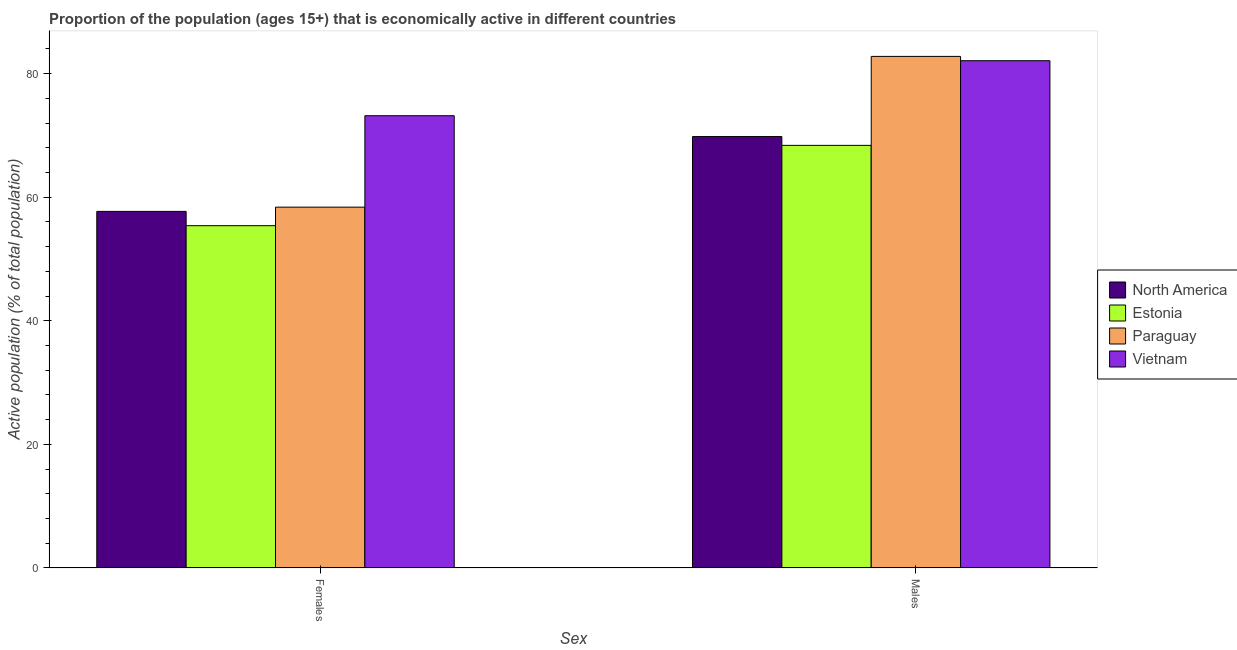How many groups of bars are there?
Your answer should be very brief. 2. Are the number of bars on each tick of the X-axis equal?
Ensure brevity in your answer.  Yes. What is the label of the 1st group of bars from the left?
Give a very brief answer. Females. What is the percentage of economically active male population in Vietnam?
Give a very brief answer. 82.1. Across all countries, what is the maximum percentage of economically active female population?
Make the answer very short. 73.2. Across all countries, what is the minimum percentage of economically active female population?
Offer a very short reply. 55.4. In which country was the percentage of economically active male population maximum?
Provide a succinct answer. Paraguay. In which country was the percentage of economically active female population minimum?
Offer a very short reply. Estonia. What is the total percentage of economically active male population in the graph?
Your answer should be very brief. 303.12. What is the difference between the percentage of economically active male population in Estonia and that in Paraguay?
Ensure brevity in your answer.  -14.4. What is the difference between the percentage of economically active male population in North America and the percentage of economically active female population in Estonia?
Your answer should be compact. 14.42. What is the average percentage of economically active male population per country?
Give a very brief answer. 75.78. What is the difference between the percentage of economically active female population and percentage of economically active male population in Estonia?
Provide a short and direct response. -13. What is the ratio of the percentage of economically active male population in Paraguay to that in North America?
Your response must be concise. 1.19. Is the percentage of economically active female population in Vietnam less than that in North America?
Keep it short and to the point. No. What does the 1st bar from the left in Females represents?
Your answer should be compact. North America. What does the 3rd bar from the right in Females represents?
Provide a short and direct response. Estonia. How many bars are there?
Provide a short and direct response. 8. How many countries are there in the graph?
Your response must be concise. 4. What is the difference between two consecutive major ticks on the Y-axis?
Provide a short and direct response. 20. How many legend labels are there?
Provide a succinct answer. 4. What is the title of the graph?
Your answer should be very brief. Proportion of the population (ages 15+) that is economically active in different countries. What is the label or title of the X-axis?
Provide a short and direct response. Sex. What is the label or title of the Y-axis?
Give a very brief answer. Active population (% of total population). What is the Active population (% of total population) in North America in Females?
Offer a terse response. 57.72. What is the Active population (% of total population) of Estonia in Females?
Provide a succinct answer. 55.4. What is the Active population (% of total population) of Paraguay in Females?
Your answer should be very brief. 58.4. What is the Active population (% of total population) in Vietnam in Females?
Give a very brief answer. 73.2. What is the Active population (% of total population) of North America in Males?
Your response must be concise. 69.82. What is the Active population (% of total population) in Estonia in Males?
Your answer should be very brief. 68.4. What is the Active population (% of total population) of Paraguay in Males?
Offer a very short reply. 82.8. What is the Active population (% of total population) in Vietnam in Males?
Offer a very short reply. 82.1. Across all Sex, what is the maximum Active population (% of total population) in North America?
Provide a succinct answer. 69.82. Across all Sex, what is the maximum Active population (% of total population) of Estonia?
Offer a very short reply. 68.4. Across all Sex, what is the maximum Active population (% of total population) of Paraguay?
Keep it short and to the point. 82.8. Across all Sex, what is the maximum Active population (% of total population) in Vietnam?
Offer a very short reply. 82.1. Across all Sex, what is the minimum Active population (% of total population) of North America?
Give a very brief answer. 57.72. Across all Sex, what is the minimum Active population (% of total population) of Estonia?
Provide a short and direct response. 55.4. Across all Sex, what is the minimum Active population (% of total population) of Paraguay?
Give a very brief answer. 58.4. Across all Sex, what is the minimum Active population (% of total population) of Vietnam?
Your answer should be very brief. 73.2. What is the total Active population (% of total population) in North America in the graph?
Your answer should be very brief. 127.54. What is the total Active population (% of total population) in Estonia in the graph?
Make the answer very short. 123.8. What is the total Active population (% of total population) of Paraguay in the graph?
Offer a very short reply. 141.2. What is the total Active population (% of total population) of Vietnam in the graph?
Provide a short and direct response. 155.3. What is the difference between the Active population (% of total population) in North America in Females and that in Males?
Keep it short and to the point. -12.11. What is the difference between the Active population (% of total population) in Estonia in Females and that in Males?
Provide a short and direct response. -13. What is the difference between the Active population (% of total population) in Paraguay in Females and that in Males?
Offer a terse response. -24.4. What is the difference between the Active population (% of total population) in Vietnam in Females and that in Males?
Offer a very short reply. -8.9. What is the difference between the Active population (% of total population) of North America in Females and the Active population (% of total population) of Estonia in Males?
Your response must be concise. -10.68. What is the difference between the Active population (% of total population) of North America in Females and the Active population (% of total population) of Paraguay in Males?
Your answer should be compact. -25.08. What is the difference between the Active population (% of total population) of North America in Females and the Active population (% of total population) of Vietnam in Males?
Give a very brief answer. -24.38. What is the difference between the Active population (% of total population) of Estonia in Females and the Active population (% of total population) of Paraguay in Males?
Keep it short and to the point. -27.4. What is the difference between the Active population (% of total population) of Estonia in Females and the Active population (% of total population) of Vietnam in Males?
Give a very brief answer. -26.7. What is the difference between the Active population (% of total population) in Paraguay in Females and the Active population (% of total population) in Vietnam in Males?
Offer a terse response. -23.7. What is the average Active population (% of total population) in North America per Sex?
Provide a succinct answer. 63.77. What is the average Active population (% of total population) in Estonia per Sex?
Offer a terse response. 61.9. What is the average Active population (% of total population) of Paraguay per Sex?
Provide a short and direct response. 70.6. What is the average Active population (% of total population) of Vietnam per Sex?
Make the answer very short. 77.65. What is the difference between the Active population (% of total population) in North America and Active population (% of total population) in Estonia in Females?
Offer a terse response. 2.32. What is the difference between the Active population (% of total population) of North America and Active population (% of total population) of Paraguay in Females?
Provide a short and direct response. -0.68. What is the difference between the Active population (% of total population) of North America and Active population (% of total population) of Vietnam in Females?
Give a very brief answer. -15.48. What is the difference between the Active population (% of total population) in Estonia and Active population (% of total population) in Paraguay in Females?
Keep it short and to the point. -3. What is the difference between the Active population (% of total population) of Estonia and Active population (% of total population) of Vietnam in Females?
Offer a terse response. -17.8. What is the difference between the Active population (% of total population) in Paraguay and Active population (% of total population) in Vietnam in Females?
Provide a succinct answer. -14.8. What is the difference between the Active population (% of total population) in North America and Active population (% of total population) in Estonia in Males?
Make the answer very short. 1.42. What is the difference between the Active population (% of total population) in North America and Active population (% of total population) in Paraguay in Males?
Your answer should be very brief. -12.98. What is the difference between the Active population (% of total population) in North America and Active population (% of total population) in Vietnam in Males?
Your response must be concise. -12.28. What is the difference between the Active population (% of total population) of Estonia and Active population (% of total population) of Paraguay in Males?
Keep it short and to the point. -14.4. What is the difference between the Active population (% of total population) in Estonia and Active population (% of total population) in Vietnam in Males?
Provide a short and direct response. -13.7. What is the difference between the Active population (% of total population) in Paraguay and Active population (% of total population) in Vietnam in Males?
Your response must be concise. 0.7. What is the ratio of the Active population (% of total population) of North America in Females to that in Males?
Your answer should be compact. 0.83. What is the ratio of the Active population (% of total population) in Estonia in Females to that in Males?
Give a very brief answer. 0.81. What is the ratio of the Active population (% of total population) in Paraguay in Females to that in Males?
Your answer should be very brief. 0.71. What is the ratio of the Active population (% of total population) in Vietnam in Females to that in Males?
Provide a succinct answer. 0.89. What is the difference between the highest and the second highest Active population (% of total population) of North America?
Ensure brevity in your answer.  12.11. What is the difference between the highest and the second highest Active population (% of total population) of Paraguay?
Offer a terse response. 24.4. What is the difference between the highest and the lowest Active population (% of total population) in North America?
Make the answer very short. 12.11. What is the difference between the highest and the lowest Active population (% of total population) in Estonia?
Your answer should be very brief. 13. What is the difference between the highest and the lowest Active population (% of total population) of Paraguay?
Ensure brevity in your answer.  24.4. 